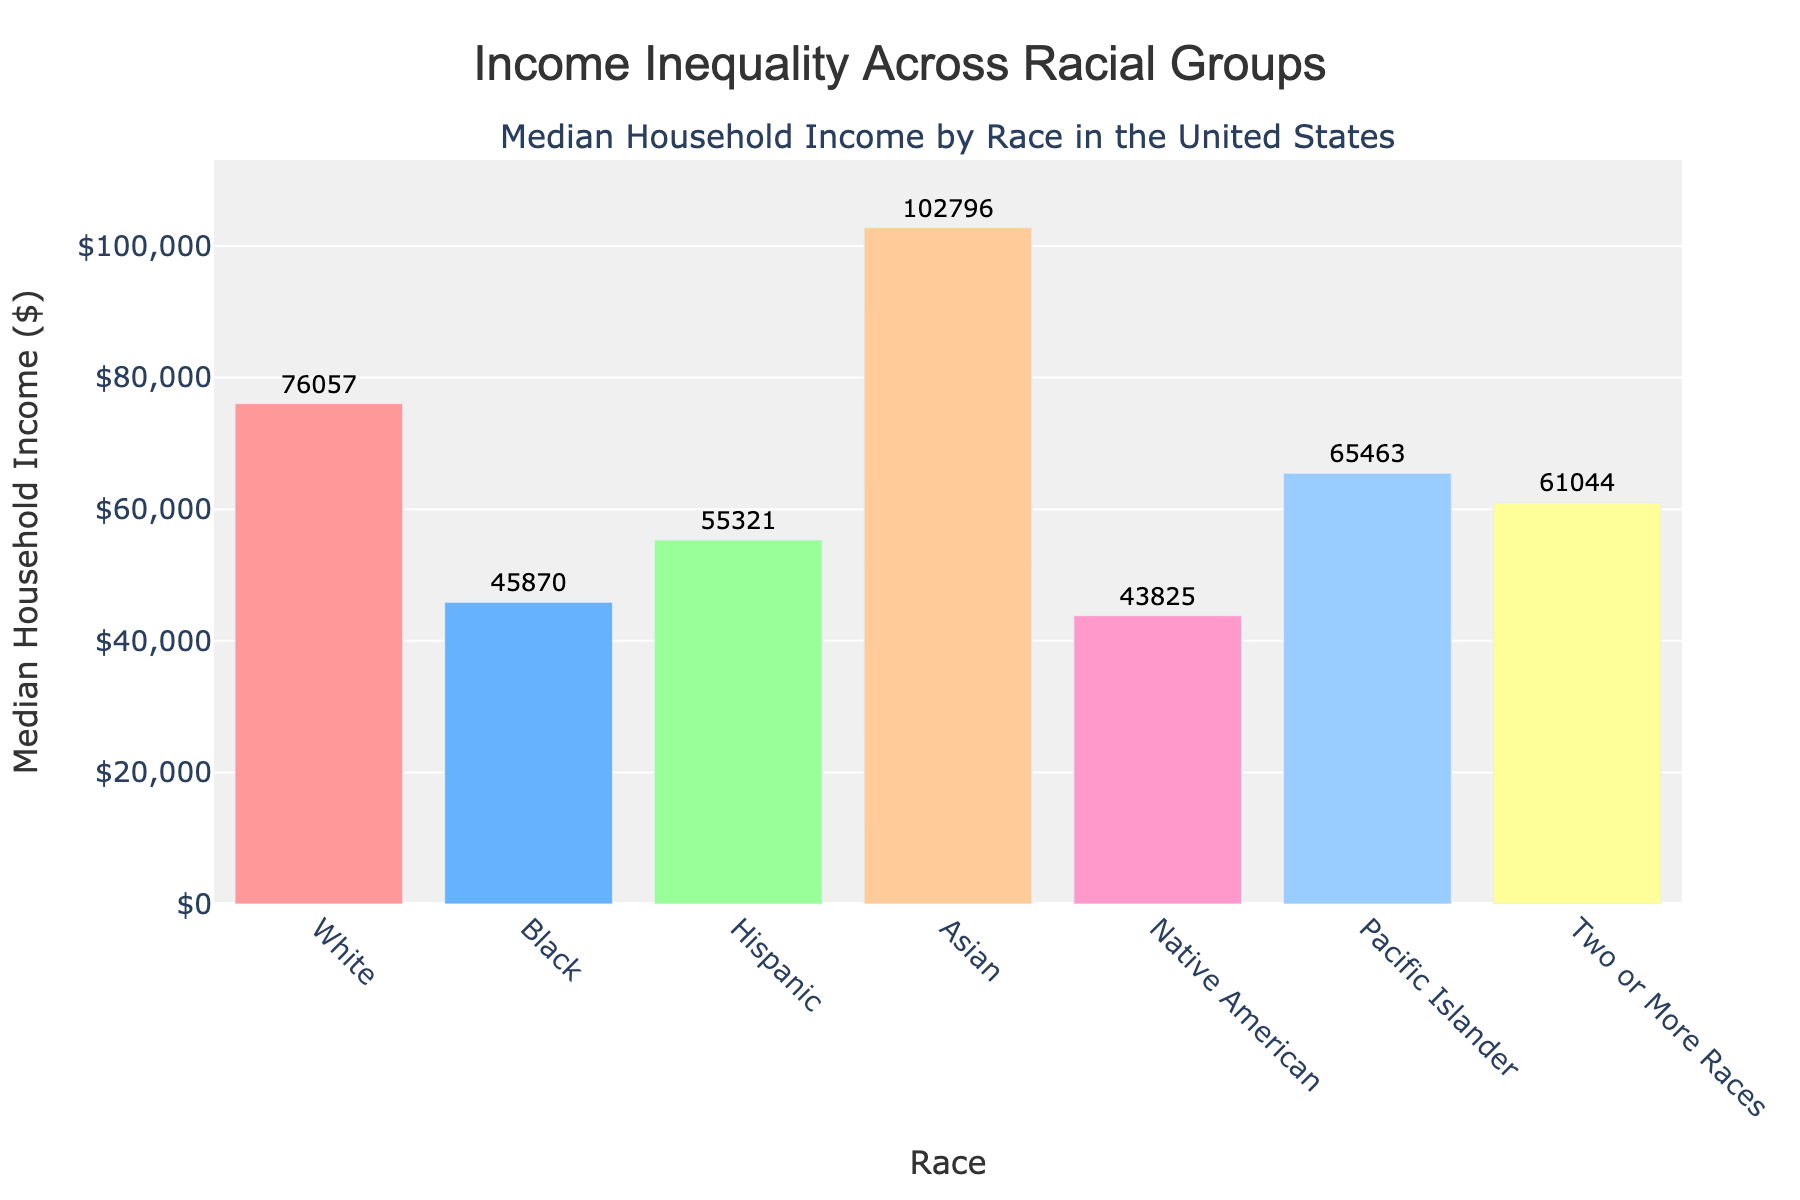Which racial group has the highest median household income? According to the figure, the bar representing Asians is the tallest. This indicates that the Asian racial group has the highest median household income.
Answer: Asian Which racial group has the lowest median household income? From the figure, the shortest bar represents the Native American group. This shows that Native Americans have the lowest median household income.
Answer: Native American How much higher is the median household income of Asians compared to Blacks? The median household income for Asians is $102,796, while for Blacks it is $45,870. The difference is calculated by subtracting the income for Blacks from that for Asians: $102,796 - $45,870 = $56,926.
Answer: $56,926 What is the combined median household income of Hispanics and Pacific Islanders? The median household income for Hispanics is $55,321 and for Pacific Islanders it is $65,463. By adding these two amounts together, we get: $55,321 + $65,463 = $120,784.
Answer: $120,784 How does the median household income of Whites compare to Asians? The median household income for Whites is $76,057, while for Asians it is $102,796. By comparing these figures, we see that the median household income for Asians is higher than that for Whites.
Answer: Asians have a higher income Which racial groups have a median household income between $40,000 and $60,000? Observing the bars in the figure, the racial groups that fall between $40,000 and $60,000 are Blacks ($45,870) and Hispanics ($55,321).
Answer: Blacks and Hispanics What is the average median household income of all racial groups? To calculate the average, we sum all the median household incomes and divide by the number of groups: (76057 + 45870 + 55321 + 102796 + 43825 + 65463 + 61044) / 7 = 449,376 / 7 = 64,196 (rounded to the nearest whole number).
Answer: $64,196 How does the income inequality between Native Americans and Pacific Islanders visually appear in the chart? In the figure, the bar for Pacific Islanders is visibly taller than that for Native Americans. This visually indicates that Pacific Islanders have a higher median household income than Native Americans.
Answer: Pacific Islanders have a higher income 